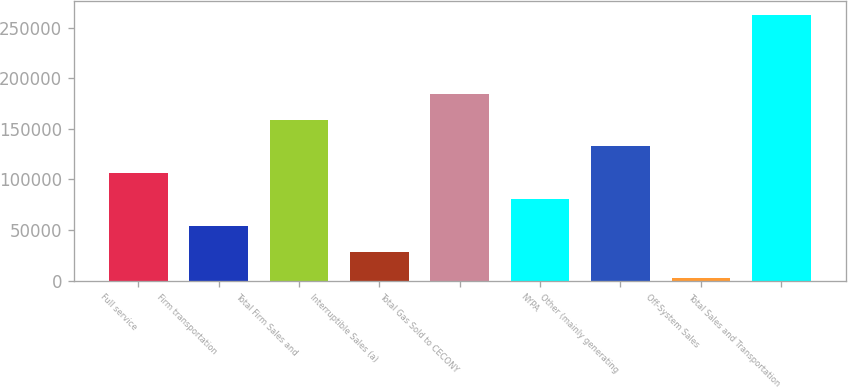<chart> <loc_0><loc_0><loc_500><loc_500><bar_chart><fcel>Full service<fcel>Firm transportation<fcel>Total Firm Sales and<fcel>Interruptible Sales (a)<fcel>Total Gas Sold to CECONY<fcel>NYPA<fcel>Other (mainly generating<fcel>Off-System Sales<fcel>Total Sales and Transportation<nl><fcel>106594<fcel>54459.6<fcel>158729<fcel>28392.3<fcel>184796<fcel>80526.9<fcel>132662<fcel>2325<fcel>262998<nl></chart> 